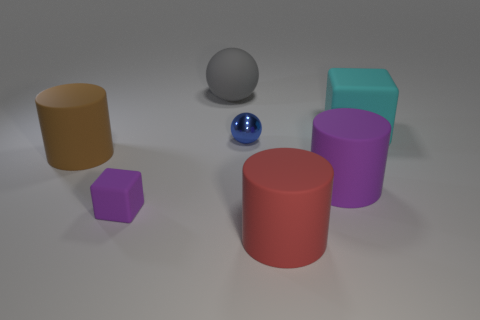Subtract all blocks. How many objects are left? 5 Add 3 tiny yellow rubber things. How many objects exist? 10 Add 2 big purple rubber cylinders. How many big purple rubber cylinders are left? 3 Add 7 blue shiny spheres. How many blue shiny spheres exist? 8 Subtract 0 cyan spheres. How many objects are left? 7 Subtract all metallic blocks. Subtract all small shiny things. How many objects are left? 6 